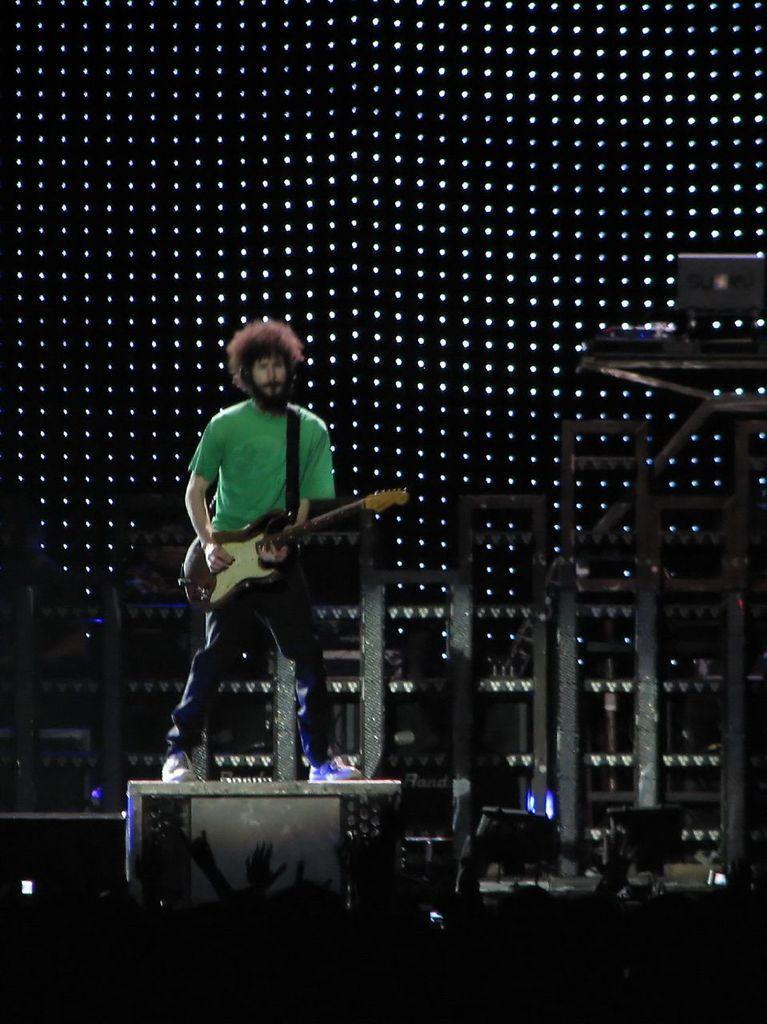Describe this image in one or two sentences. In the middle of the image a man is standing and playing guitar. Behind him there is a screen. 